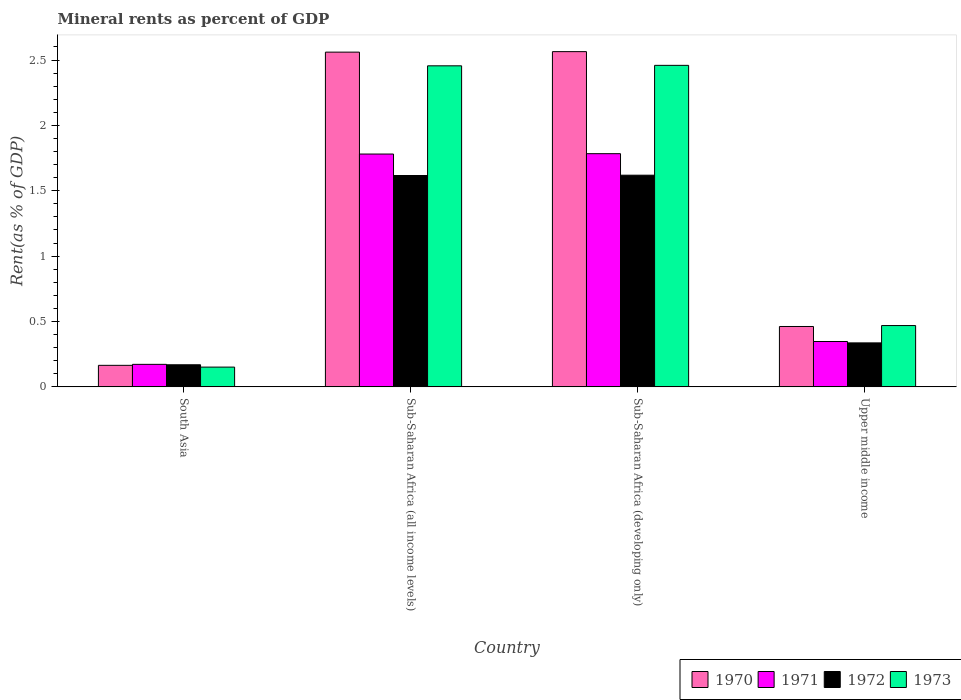How many groups of bars are there?
Offer a very short reply. 4. How many bars are there on the 3rd tick from the left?
Your answer should be very brief. 4. How many bars are there on the 2nd tick from the right?
Give a very brief answer. 4. What is the label of the 2nd group of bars from the left?
Offer a terse response. Sub-Saharan Africa (all income levels). What is the mineral rent in 1973 in Sub-Saharan Africa (all income levels)?
Offer a very short reply. 2.46. Across all countries, what is the maximum mineral rent in 1973?
Your answer should be compact. 2.46. Across all countries, what is the minimum mineral rent in 1971?
Provide a succinct answer. 0.17. In which country was the mineral rent in 1973 maximum?
Keep it short and to the point. Sub-Saharan Africa (developing only). What is the total mineral rent in 1970 in the graph?
Offer a terse response. 5.75. What is the difference between the mineral rent in 1971 in South Asia and that in Sub-Saharan Africa (all income levels)?
Keep it short and to the point. -1.61. What is the difference between the mineral rent in 1971 in Upper middle income and the mineral rent in 1972 in Sub-Saharan Africa (developing only)?
Offer a terse response. -1.27. What is the average mineral rent in 1972 per country?
Make the answer very short. 0.94. What is the difference between the mineral rent of/in 1971 and mineral rent of/in 1972 in Sub-Saharan Africa (developing only)?
Your answer should be very brief. 0.16. In how many countries, is the mineral rent in 1972 greater than 2.4 %?
Make the answer very short. 0. What is the ratio of the mineral rent in 1973 in Sub-Saharan Africa (developing only) to that in Upper middle income?
Ensure brevity in your answer.  5.24. Is the difference between the mineral rent in 1971 in South Asia and Upper middle income greater than the difference between the mineral rent in 1972 in South Asia and Upper middle income?
Give a very brief answer. No. What is the difference between the highest and the second highest mineral rent in 1973?
Your answer should be compact. -1.99. What is the difference between the highest and the lowest mineral rent in 1970?
Your answer should be very brief. 2.4. Is the sum of the mineral rent in 1971 in Sub-Saharan Africa (developing only) and Upper middle income greater than the maximum mineral rent in 1973 across all countries?
Keep it short and to the point. No. Is it the case that in every country, the sum of the mineral rent in 1970 and mineral rent in 1971 is greater than the sum of mineral rent in 1972 and mineral rent in 1973?
Offer a very short reply. No. What does the 3rd bar from the left in South Asia represents?
Your response must be concise. 1972. What does the 4th bar from the right in Sub-Saharan Africa (all income levels) represents?
Provide a succinct answer. 1970. How many bars are there?
Offer a terse response. 16. Are all the bars in the graph horizontal?
Offer a very short reply. No. How many countries are there in the graph?
Offer a very short reply. 4. Are the values on the major ticks of Y-axis written in scientific E-notation?
Give a very brief answer. No. Does the graph contain any zero values?
Your answer should be compact. No. Does the graph contain grids?
Provide a succinct answer. No. Where does the legend appear in the graph?
Provide a short and direct response. Bottom right. How are the legend labels stacked?
Offer a very short reply. Horizontal. What is the title of the graph?
Your response must be concise. Mineral rents as percent of GDP. Does "1978" appear as one of the legend labels in the graph?
Your answer should be compact. No. What is the label or title of the X-axis?
Provide a succinct answer. Country. What is the label or title of the Y-axis?
Ensure brevity in your answer.  Rent(as % of GDP). What is the Rent(as % of GDP) in 1970 in South Asia?
Provide a succinct answer. 0.16. What is the Rent(as % of GDP) of 1971 in South Asia?
Give a very brief answer. 0.17. What is the Rent(as % of GDP) of 1972 in South Asia?
Provide a short and direct response. 0.17. What is the Rent(as % of GDP) of 1973 in South Asia?
Provide a short and direct response. 0.15. What is the Rent(as % of GDP) in 1970 in Sub-Saharan Africa (all income levels)?
Make the answer very short. 2.56. What is the Rent(as % of GDP) of 1971 in Sub-Saharan Africa (all income levels)?
Your answer should be compact. 1.78. What is the Rent(as % of GDP) in 1972 in Sub-Saharan Africa (all income levels)?
Provide a succinct answer. 1.62. What is the Rent(as % of GDP) of 1973 in Sub-Saharan Africa (all income levels)?
Ensure brevity in your answer.  2.46. What is the Rent(as % of GDP) of 1970 in Sub-Saharan Africa (developing only)?
Keep it short and to the point. 2.56. What is the Rent(as % of GDP) of 1971 in Sub-Saharan Africa (developing only)?
Provide a succinct answer. 1.78. What is the Rent(as % of GDP) in 1972 in Sub-Saharan Africa (developing only)?
Give a very brief answer. 1.62. What is the Rent(as % of GDP) in 1973 in Sub-Saharan Africa (developing only)?
Your answer should be compact. 2.46. What is the Rent(as % of GDP) in 1970 in Upper middle income?
Make the answer very short. 0.46. What is the Rent(as % of GDP) of 1971 in Upper middle income?
Provide a short and direct response. 0.35. What is the Rent(as % of GDP) of 1972 in Upper middle income?
Your answer should be very brief. 0.34. What is the Rent(as % of GDP) in 1973 in Upper middle income?
Keep it short and to the point. 0.47. Across all countries, what is the maximum Rent(as % of GDP) of 1970?
Your answer should be compact. 2.56. Across all countries, what is the maximum Rent(as % of GDP) in 1971?
Offer a very short reply. 1.78. Across all countries, what is the maximum Rent(as % of GDP) of 1972?
Ensure brevity in your answer.  1.62. Across all countries, what is the maximum Rent(as % of GDP) in 1973?
Your answer should be very brief. 2.46. Across all countries, what is the minimum Rent(as % of GDP) in 1970?
Make the answer very short. 0.16. Across all countries, what is the minimum Rent(as % of GDP) of 1971?
Your answer should be very brief. 0.17. Across all countries, what is the minimum Rent(as % of GDP) in 1972?
Keep it short and to the point. 0.17. Across all countries, what is the minimum Rent(as % of GDP) of 1973?
Make the answer very short. 0.15. What is the total Rent(as % of GDP) in 1970 in the graph?
Provide a succinct answer. 5.75. What is the total Rent(as % of GDP) in 1971 in the graph?
Make the answer very short. 4.08. What is the total Rent(as % of GDP) of 1972 in the graph?
Provide a short and direct response. 3.74. What is the total Rent(as % of GDP) in 1973 in the graph?
Your answer should be very brief. 5.54. What is the difference between the Rent(as % of GDP) in 1970 in South Asia and that in Sub-Saharan Africa (all income levels)?
Your answer should be very brief. -2.4. What is the difference between the Rent(as % of GDP) of 1971 in South Asia and that in Sub-Saharan Africa (all income levels)?
Offer a very short reply. -1.61. What is the difference between the Rent(as % of GDP) of 1972 in South Asia and that in Sub-Saharan Africa (all income levels)?
Give a very brief answer. -1.45. What is the difference between the Rent(as % of GDP) in 1973 in South Asia and that in Sub-Saharan Africa (all income levels)?
Keep it short and to the point. -2.3. What is the difference between the Rent(as % of GDP) of 1970 in South Asia and that in Sub-Saharan Africa (developing only)?
Your answer should be very brief. -2.4. What is the difference between the Rent(as % of GDP) in 1971 in South Asia and that in Sub-Saharan Africa (developing only)?
Give a very brief answer. -1.61. What is the difference between the Rent(as % of GDP) in 1972 in South Asia and that in Sub-Saharan Africa (developing only)?
Keep it short and to the point. -1.45. What is the difference between the Rent(as % of GDP) in 1973 in South Asia and that in Sub-Saharan Africa (developing only)?
Your response must be concise. -2.31. What is the difference between the Rent(as % of GDP) of 1970 in South Asia and that in Upper middle income?
Your answer should be very brief. -0.3. What is the difference between the Rent(as % of GDP) of 1971 in South Asia and that in Upper middle income?
Make the answer very short. -0.17. What is the difference between the Rent(as % of GDP) in 1972 in South Asia and that in Upper middle income?
Keep it short and to the point. -0.17. What is the difference between the Rent(as % of GDP) in 1973 in South Asia and that in Upper middle income?
Your answer should be compact. -0.32. What is the difference between the Rent(as % of GDP) of 1970 in Sub-Saharan Africa (all income levels) and that in Sub-Saharan Africa (developing only)?
Your answer should be very brief. -0. What is the difference between the Rent(as % of GDP) in 1971 in Sub-Saharan Africa (all income levels) and that in Sub-Saharan Africa (developing only)?
Make the answer very short. -0. What is the difference between the Rent(as % of GDP) in 1972 in Sub-Saharan Africa (all income levels) and that in Sub-Saharan Africa (developing only)?
Ensure brevity in your answer.  -0. What is the difference between the Rent(as % of GDP) in 1973 in Sub-Saharan Africa (all income levels) and that in Sub-Saharan Africa (developing only)?
Your response must be concise. -0. What is the difference between the Rent(as % of GDP) in 1970 in Sub-Saharan Africa (all income levels) and that in Upper middle income?
Give a very brief answer. 2.1. What is the difference between the Rent(as % of GDP) in 1971 in Sub-Saharan Africa (all income levels) and that in Upper middle income?
Provide a succinct answer. 1.43. What is the difference between the Rent(as % of GDP) of 1972 in Sub-Saharan Africa (all income levels) and that in Upper middle income?
Offer a very short reply. 1.28. What is the difference between the Rent(as % of GDP) of 1973 in Sub-Saharan Africa (all income levels) and that in Upper middle income?
Your response must be concise. 1.99. What is the difference between the Rent(as % of GDP) in 1970 in Sub-Saharan Africa (developing only) and that in Upper middle income?
Ensure brevity in your answer.  2.1. What is the difference between the Rent(as % of GDP) of 1971 in Sub-Saharan Africa (developing only) and that in Upper middle income?
Ensure brevity in your answer.  1.44. What is the difference between the Rent(as % of GDP) of 1972 in Sub-Saharan Africa (developing only) and that in Upper middle income?
Give a very brief answer. 1.28. What is the difference between the Rent(as % of GDP) in 1973 in Sub-Saharan Africa (developing only) and that in Upper middle income?
Provide a short and direct response. 1.99. What is the difference between the Rent(as % of GDP) of 1970 in South Asia and the Rent(as % of GDP) of 1971 in Sub-Saharan Africa (all income levels)?
Offer a terse response. -1.62. What is the difference between the Rent(as % of GDP) in 1970 in South Asia and the Rent(as % of GDP) in 1972 in Sub-Saharan Africa (all income levels)?
Offer a very short reply. -1.45. What is the difference between the Rent(as % of GDP) in 1970 in South Asia and the Rent(as % of GDP) in 1973 in Sub-Saharan Africa (all income levels)?
Keep it short and to the point. -2.29. What is the difference between the Rent(as % of GDP) of 1971 in South Asia and the Rent(as % of GDP) of 1972 in Sub-Saharan Africa (all income levels)?
Provide a short and direct response. -1.44. What is the difference between the Rent(as % of GDP) in 1971 in South Asia and the Rent(as % of GDP) in 1973 in Sub-Saharan Africa (all income levels)?
Your response must be concise. -2.28. What is the difference between the Rent(as % of GDP) of 1972 in South Asia and the Rent(as % of GDP) of 1973 in Sub-Saharan Africa (all income levels)?
Make the answer very short. -2.29. What is the difference between the Rent(as % of GDP) of 1970 in South Asia and the Rent(as % of GDP) of 1971 in Sub-Saharan Africa (developing only)?
Your answer should be compact. -1.62. What is the difference between the Rent(as % of GDP) in 1970 in South Asia and the Rent(as % of GDP) in 1972 in Sub-Saharan Africa (developing only)?
Your response must be concise. -1.45. What is the difference between the Rent(as % of GDP) of 1970 in South Asia and the Rent(as % of GDP) of 1973 in Sub-Saharan Africa (developing only)?
Make the answer very short. -2.29. What is the difference between the Rent(as % of GDP) in 1971 in South Asia and the Rent(as % of GDP) in 1972 in Sub-Saharan Africa (developing only)?
Offer a very short reply. -1.45. What is the difference between the Rent(as % of GDP) of 1971 in South Asia and the Rent(as % of GDP) of 1973 in Sub-Saharan Africa (developing only)?
Provide a succinct answer. -2.29. What is the difference between the Rent(as % of GDP) in 1972 in South Asia and the Rent(as % of GDP) in 1973 in Sub-Saharan Africa (developing only)?
Give a very brief answer. -2.29. What is the difference between the Rent(as % of GDP) in 1970 in South Asia and the Rent(as % of GDP) in 1971 in Upper middle income?
Provide a short and direct response. -0.18. What is the difference between the Rent(as % of GDP) of 1970 in South Asia and the Rent(as % of GDP) of 1972 in Upper middle income?
Offer a very short reply. -0.17. What is the difference between the Rent(as % of GDP) of 1970 in South Asia and the Rent(as % of GDP) of 1973 in Upper middle income?
Your answer should be very brief. -0.3. What is the difference between the Rent(as % of GDP) in 1971 in South Asia and the Rent(as % of GDP) in 1972 in Upper middle income?
Give a very brief answer. -0.16. What is the difference between the Rent(as % of GDP) in 1971 in South Asia and the Rent(as % of GDP) in 1973 in Upper middle income?
Give a very brief answer. -0.3. What is the difference between the Rent(as % of GDP) in 1972 in South Asia and the Rent(as % of GDP) in 1973 in Upper middle income?
Your answer should be very brief. -0.3. What is the difference between the Rent(as % of GDP) of 1970 in Sub-Saharan Africa (all income levels) and the Rent(as % of GDP) of 1971 in Sub-Saharan Africa (developing only)?
Make the answer very short. 0.78. What is the difference between the Rent(as % of GDP) of 1970 in Sub-Saharan Africa (all income levels) and the Rent(as % of GDP) of 1972 in Sub-Saharan Africa (developing only)?
Make the answer very short. 0.94. What is the difference between the Rent(as % of GDP) in 1970 in Sub-Saharan Africa (all income levels) and the Rent(as % of GDP) in 1973 in Sub-Saharan Africa (developing only)?
Provide a succinct answer. 0.1. What is the difference between the Rent(as % of GDP) of 1971 in Sub-Saharan Africa (all income levels) and the Rent(as % of GDP) of 1972 in Sub-Saharan Africa (developing only)?
Offer a terse response. 0.16. What is the difference between the Rent(as % of GDP) of 1971 in Sub-Saharan Africa (all income levels) and the Rent(as % of GDP) of 1973 in Sub-Saharan Africa (developing only)?
Offer a terse response. -0.68. What is the difference between the Rent(as % of GDP) of 1972 in Sub-Saharan Africa (all income levels) and the Rent(as % of GDP) of 1973 in Sub-Saharan Africa (developing only)?
Keep it short and to the point. -0.84. What is the difference between the Rent(as % of GDP) in 1970 in Sub-Saharan Africa (all income levels) and the Rent(as % of GDP) in 1971 in Upper middle income?
Provide a succinct answer. 2.21. What is the difference between the Rent(as % of GDP) in 1970 in Sub-Saharan Africa (all income levels) and the Rent(as % of GDP) in 1972 in Upper middle income?
Keep it short and to the point. 2.22. What is the difference between the Rent(as % of GDP) in 1970 in Sub-Saharan Africa (all income levels) and the Rent(as % of GDP) in 1973 in Upper middle income?
Make the answer very short. 2.09. What is the difference between the Rent(as % of GDP) of 1971 in Sub-Saharan Africa (all income levels) and the Rent(as % of GDP) of 1972 in Upper middle income?
Provide a succinct answer. 1.44. What is the difference between the Rent(as % of GDP) in 1971 in Sub-Saharan Africa (all income levels) and the Rent(as % of GDP) in 1973 in Upper middle income?
Ensure brevity in your answer.  1.31. What is the difference between the Rent(as % of GDP) in 1972 in Sub-Saharan Africa (all income levels) and the Rent(as % of GDP) in 1973 in Upper middle income?
Offer a very short reply. 1.15. What is the difference between the Rent(as % of GDP) in 1970 in Sub-Saharan Africa (developing only) and the Rent(as % of GDP) in 1971 in Upper middle income?
Keep it short and to the point. 2.22. What is the difference between the Rent(as % of GDP) in 1970 in Sub-Saharan Africa (developing only) and the Rent(as % of GDP) in 1972 in Upper middle income?
Your response must be concise. 2.23. What is the difference between the Rent(as % of GDP) in 1970 in Sub-Saharan Africa (developing only) and the Rent(as % of GDP) in 1973 in Upper middle income?
Your response must be concise. 2.1. What is the difference between the Rent(as % of GDP) of 1971 in Sub-Saharan Africa (developing only) and the Rent(as % of GDP) of 1972 in Upper middle income?
Offer a very short reply. 1.45. What is the difference between the Rent(as % of GDP) in 1971 in Sub-Saharan Africa (developing only) and the Rent(as % of GDP) in 1973 in Upper middle income?
Offer a terse response. 1.31. What is the difference between the Rent(as % of GDP) of 1972 in Sub-Saharan Africa (developing only) and the Rent(as % of GDP) of 1973 in Upper middle income?
Keep it short and to the point. 1.15. What is the average Rent(as % of GDP) of 1970 per country?
Your answer should be very brief. 1.44. What is the average Rent(as % of GDP) in 1971 per country?
Provide a succinct answer. 1.02. What is the average Rent(as % of GDP) in 1972 per country?
Your answer should be compact. 0.94. What is the average Rent(as % of GDP) of 1973 per country?
Your answer should be compact. 1.38. What is the difference between the Rent(as % of GDP) of 1970 and Rent(as % of GDP) of 1971 in South Asia?
Offer a terse response. -0.01. What is the difference between the Rent(as % of GDP) of 1970 and Rent(as % of GDP) of 1972 in South Asia?
Ensure brevity in your answer.  -0. What is the difference between the Rent(as % of GDP) of 1970 and Rent(as % of GDP) of 1973 in South Asia?
Your answer should be very brief. 0.01. What is the difference between the Rent(as % of GDP) of 1971 and Rent(as % of GDP) of 1972 in South Asia?
Offer a very short reply. 0. What is the difference between the Rent(as % of GDP) in 1971 and Rent(as % of GDP) in 1973 in South Asia?
Provide a short and direct response. 0.02. What is the difference between the Rent(as % of GDP) in 1972 and Rent(as % of GDP) in 1973 in South Asia?
Offer a terse response. 0.02. What is the difference between the Rent(as % of GDP) in 1970 and Rent(as % of GDP) in 1971 in Sub-Saharan Africa (all income levels)?
Your response must be concise. 0.78. What is the difference between the Rent(as % of GDP) in 1970 and Rent(as % of GDP) in 1972 in Sub-Saharan Africa (all income levels)?
Your answer should be compact. 0.94. What is the difference between the Rent(as % of GDP) in 1970 and Rent(as % of GDP) in 1973 in Sub-Saharan Africa (all income levels)?
Your response must be concise. 0.1. What is the difference between the Rent(as % of GDP) of 1971 and Rent(as % of GDP) of 1972 in Sub-Saharan Africa (all income levels)?
Your answer should be very brief. 0.16. What is the difference between the Rent(as % of GDP) of 1971 and Rent(as % of GDP) of 1973 in Sub-Saharan Africa (all income levels)?
Provide a succinct answer. -0.67. What is the difference between the Rent(as % of GDP) in 1972 and Rent(as % of GDP) in 1973 in Sub-Saharan Africa (all income levels)?
Your response must be concise. -0.84. What is the difference between the Rent(as % of GDP) of 1970 and Rent(as % of GDP) of 1971 in Sub-Saharan Africa (developing only)?
Make the answer very short. 0.78. What is the difference between the Rent(as % of GDP) in 1970 and Rent(as % of GDP) in 1972 in Sub-Saharan Africa (developing only)?
Make the answer very short. 0.95. What is the difference between the Rent(as % of GDP) of 1970 and Rent(as % of GDP) of 1973 in Sub-Saharan Africa (developing only)?
Your response must be concise. 0.1. What is the difference between the Rent(as % of GDP) of 1971 and Rent(as % of GDP) of 1972 in Sub-Saharan Africa (developing only)?
Give a very brief answer. 0.16. What is the difference between the Rent(as % of GDP) of 1971 and Rent(as % of GDP) of 1973 in Sub-Saharan Africa (developing only)?
Provide a short and direct response. -0.68. What is the difference between the Rent(as % of GDP) of 1972 and Rent(as % of GDP) of 1973 in Sub-Saharan Africa (developing only)?
Keep it short and to the point. -0.84. What is the difference between the Rent(as % of GDP) of 1970 and Rent(as % of GDP) of 1971 in Upper middle income?
Keep it short and to the point. 0.11. What is the difference between the Rent(as % of GDP) in 1970 and Rent(as % of GDP) in 1972 in Upper middle income?
Provide a succinct answer. 0.13. What is the difference between the Rent(as % of GDP) in 1970 and Rent(as % of GDP) in 1973 in Upper middle income?
Your answer should be very brief. -0.01. What is the difference between the Rent(as % of GDP) in 1971 and Rent(as % of GDP) in 1972 in Upper middle income?
Your answer should be very brief. 0.01. What is the difference between the Rent(as % of GDP) of 1971 and Rent(as % of GDP) of 1973 in Upper middle income?
Give a very brief answer. -0.12. What is the difference between the Rent(as % of GDP) in 1972 and Rent(as % of GDP) in 1973 in Upper middle income?
Your response must be concise. -0.13. What is the ratio of the Rent(as % of GDP) of 1970 in South Asia to that in Sub-Saharan Africa (all income levels)?
Provide a succinct answer. 0.06. What is the ratio of the Rent(as % of GDP) in 1971 in South Asia to that in Sub-Saharan Africa (all income levels)?
Your response must be concise. 0.1. What is the ratio of the Rent(as % of GDP) of 1972 in South Asia to that in Sub-Saharan Africa (all income levels)?
Offer a very short reply. 0.1. What is the ratio of the Rent(as % of GDP) in 1973 in South Asia to that in Sub-Saharan Africa (all income levels)?
Your answer should be compact. 0.06. What is the ratio of the Rent(as % of GDP) of 1970 in South Asia to that in Sub-Saharan Africa (developing only)?
Your response must be concise. 0.06. What is the ratio of the Rent(as % of GDP) in 1971 in South Asia to that in Sub-Saharan Africa (developing only)?
Your response must be concise. 0.1. What is the ratio of the Rent(as % of GDP) in 1972 in South Asia to that in Sub-Saharan Africa (developing only)?
Give a very brief answer. 0.1. What is the ratio of the Rent(as % of GDP) in 1973 in South Asia to that in Sub-Saharan Africa (developing only)?
Ensure brevity in your answer.  0.06. What is the ratio of the Rent(as % of GDP) of 1970 in South Asia to that in Upper middle income?
Give a very brief answer. 0.36. What is the ratio of the Rent(as % of GDP) of 1971 in South Asia to that in Upper middle income?
Keep it short and to the point. 0.5. What is the ratio of the Rent(as % of GDP) in 1972 in South Asia to that in Upper middle income?
Your answer should be compact. 0.5. What is the ratio of the Rent(as % of GDP) of 1973 in South Asia to that in Upper middle income?
Offer a terse response. 0.32. What is the ratio of the Rent(as % of GDP) in 1970 in Sub-Saharan Africa (all income levels) to that in Upper middle income?
Give a very brief answer. 5.54. What is the ratio of the Rent(as % of GDP) of 1971 in Sub-Saharan Africa (all income levels) to that in Upper middle income?
Keep it short and to the point. 5.13. What is the ratio of the Rent(as % of GDP) of 1972 in Sub-Saharan Africa (all income levels) to that in Upper middle income?
Your answer should be very brief. 4.81. What is the ratio of the Rent(as % of GDP) of 1973 in Sub-Saharan Africa (all income levels) to that in Upper middle income?
Provide a succinct answer. 5.24. What is the ratio of the Rent(as % of GDP) of 1970 in Sub-Saharan Africa (developing only) to that in Upper middle income?
Offer a very short reply. 5.55. What is the ratio of the Rent(as % of GDP) in 1971 in Sub-Saharan Africa (developing only) to that in Upper middle income?
Your answer should be compact. 5.14. What is the ratio of the Rent(as % of GDP) in 1972 in Sub-Saharan Africa (developing only) to that in Upper middle income?
Offer a terse response. 4.81. What is the ratio of the Rent(as % of GDP) of 1973 in Sub-Saharan Africa (developing only) to that in Upper middle income?
Make the answer very short. 5.24. What is the difference between the highest and the second highest Rent(as % of GDP) of 1970?
Provide a short and direct response. 0. What is the difference between the highest and the second highest Rent(as % of GDP) of 1971?
Keep it short and to the point. 0. What is the difference between the highest and the second highest Rent(as % of GDP) in 1972?
Provide a short and direct response. 0. What is the difference between the highest and the second highest Rent(as % of GDP) of 1973?
Your answer should be very brief. 0. What is the difference between the highest and the lowest Rent(as % of GDP) of 1970?
Offer a terse response. 2.4. What is the difference between the highest and the lowest Rent(as % of GDP) in 1971?
Provide a short and direct response. 1.61. What is the difference between the highest and the lowest Rent(as % of GDP) of 1972?
Your answer should be compact. 1.45. What is the difference between the highest and the lowest Rent(as % of GDP) in 1973?
Give a very brief answer. 2.31. 